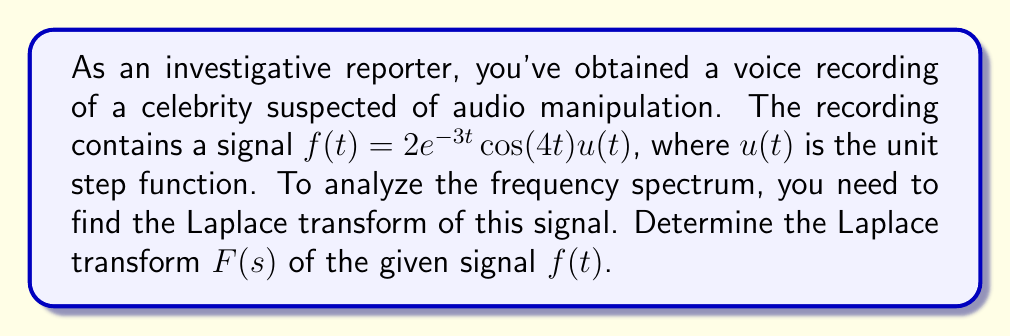Provide a solution to this math problem. To find the Laplace transform of the given signal, we'll follow these steps:

1) The general form of the Laplace transform is:

   $$F(s) = \int_0^\infty f(t)e^{-st}dt$$

2) Our signal is $f(t) = 2e^{-3t}\cos(4t)u(t)$. The unit step function $u(t)$ implies that the signal starts at $t=0$, which aligns with our integral limits.

3) We can use the following property of Laplace transforms:

   If $F(s) = \mathcal{L}\{f(t)\}$, then $\mathcal{L}\{e^{at}f(t)\} = F(s-a)$

4) In our case, we have $e^{-3t}$, so we'll use $F(s+3)$ instead of $F(s)$.

5) We also know the Laplace transform of $\cos(bt)$:

   $$\mathcal{L}\{\cos(bt)\} = \frac{s}{s^2 + b^2}$$

6) Combining steps 3-5, we can write:

   $$F(s) = 2 \cdot \frac{s+3}{(s+3)^2 + 4^2}$$

7) Simplify:

   $$F(s) = \frac{2(s+3)}{s^2 + 6s + 25}$$

This is the Laplace transform of the given signal.
Answer: $$F(s) = \frac{2(s+3)}{s^2 + 6s + 25}$$ 